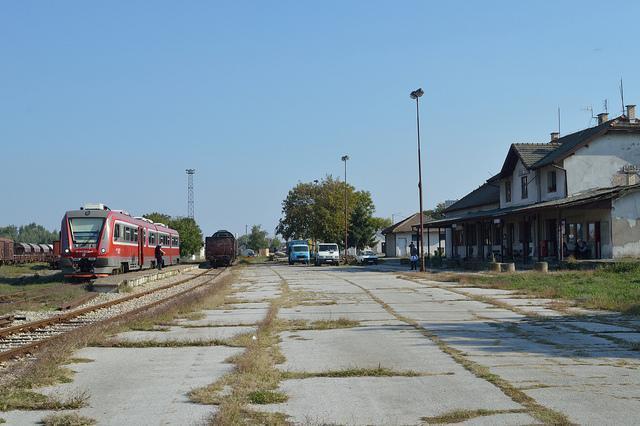What is the old rusted freight car in the background probably used to carry?
Choose the correct response, then elucidate: 'Answer: answer
Rationale: rationale.'
Options: Oil, gas, water, coal. Answer: coal.
Rationale: The top of the red wagon has black stuff. 